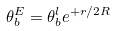<formula> <loc_0><loc_0><loc_500><loc_500>\theta _ { b } ^ { E } = \theta _ { b } ^ { l } e ^ { + r / 2 R }</formula> 